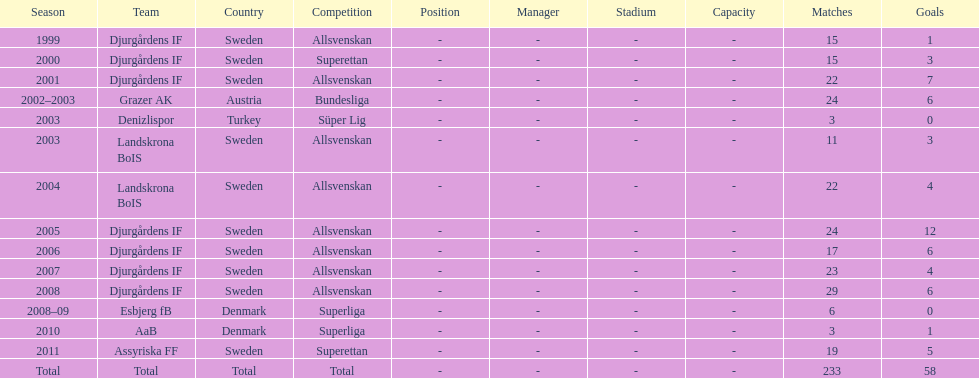How many matches overall were there? 233. 